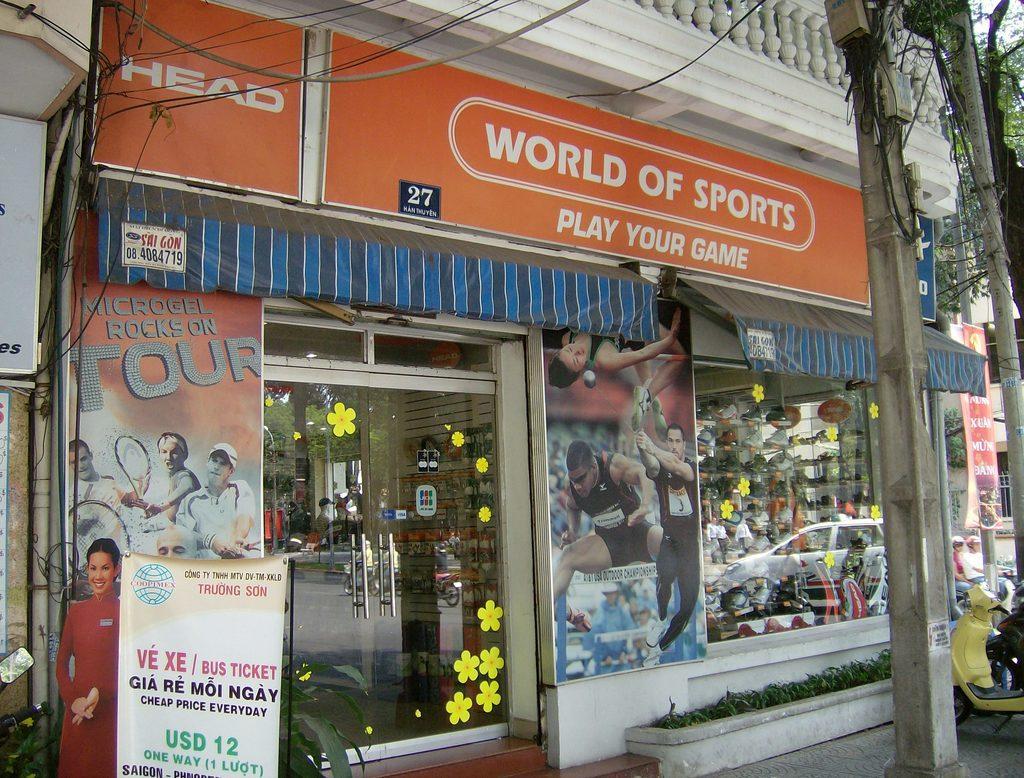Could you give a brief overview of what you see in this image? In this image we can see a store, name board, advertisements, objects arranged in the racks in rows, motor vehicles on the road, shrubs, trees, electric poles, electric cables and sky. 